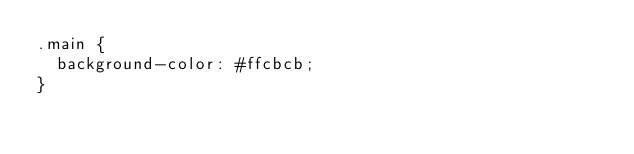<code> <loc_0><loc_0><loc_500><loc_500><_CSS_>.main {
	background-color: #ffcbcb;
}
</code> 